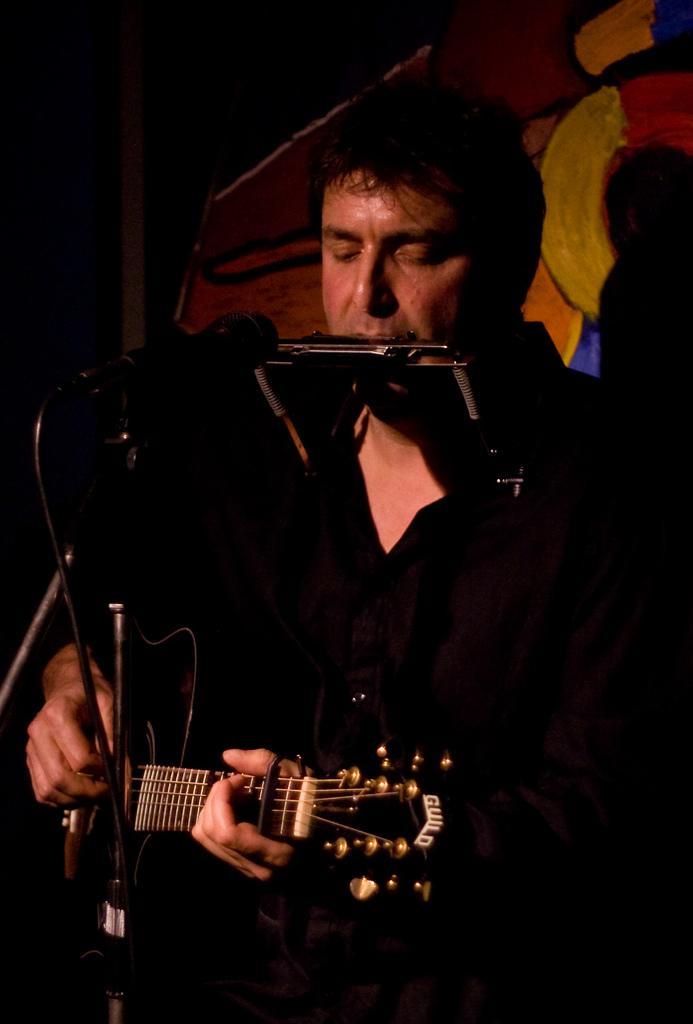Please provide a concise description of this image. This image there is a person standing is playing a guitar. There is a mike in front of him. There is a person at the back side. 